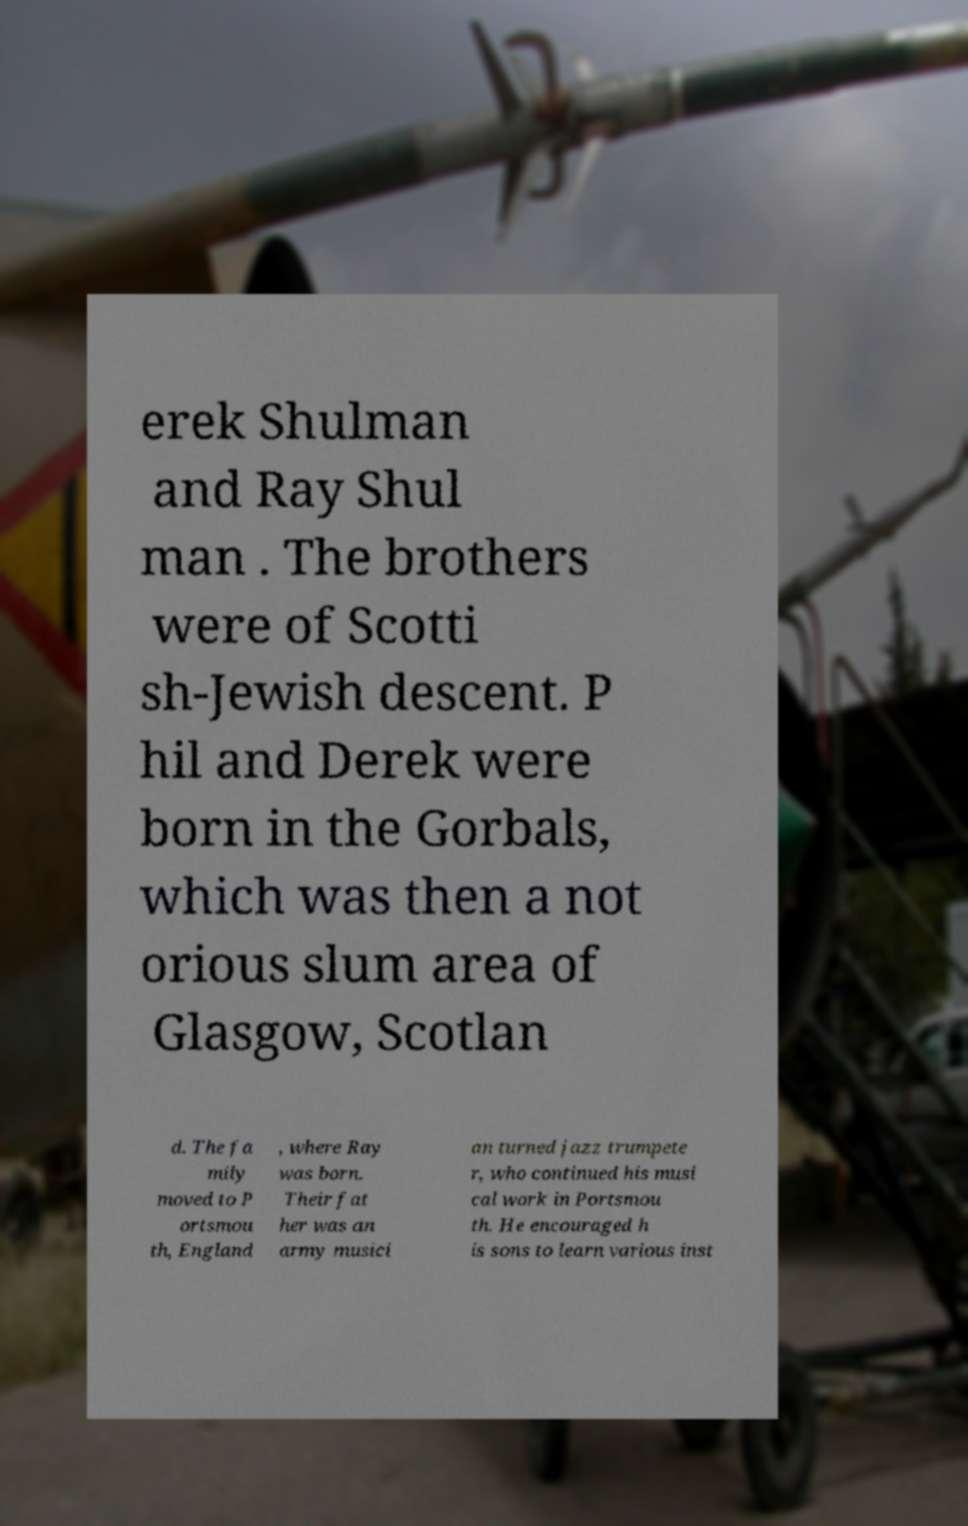Please identify and transcribe the text found in this image. erek Shulman and Ray Shul man . The brothers were of Scotti sh-Jewish descent. P hil and Derek were born in the Gorbals, which was then a not orious slum area of Glasgow, Scotlan d. The fa mily moved to P ortsmou th, England , where Ray was born. Their fat her was an army musici an turned jazz trumpete r, who continued his musi cal work in Portsmou th. He encouraged h is sons to learn various inst 